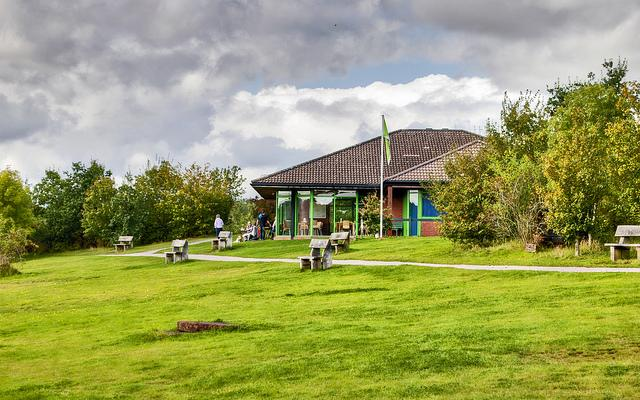What flowers might grow wild in this environment? dandelions 